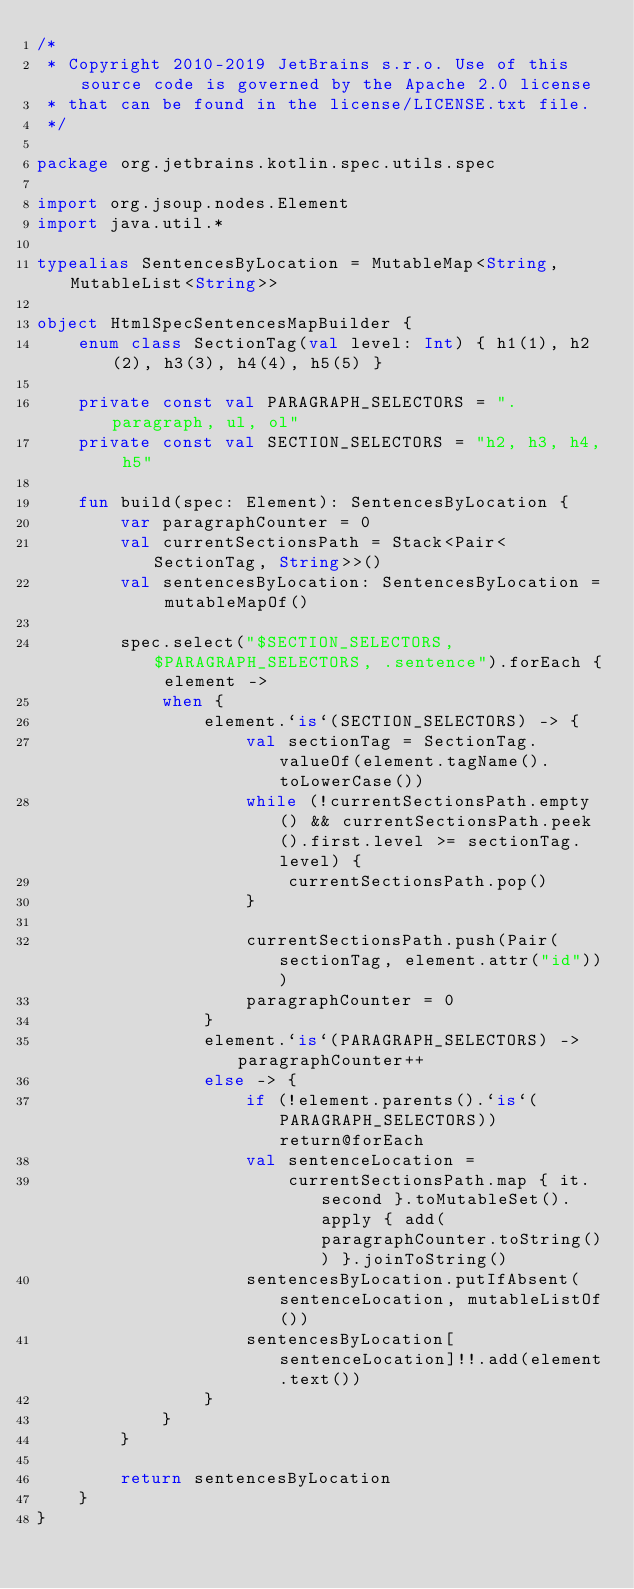Convert code to text. <code><loc_0><loc_0><loc_500><loc_500><_Kotlin_>/*
 * Copyright 2010-2019 JetBrains s.r.o. Use of this source code is governed by the Apache 2.0 license
 * that can be found in the license/LICENSE.txt file.
 */

package org.jetbrains.kotlin.spec.utils.spec

import org.jsoup.nodes.Element
import java.util.*

typealias SentencesByLocation = MutableMap<String, MutableList<String>>

object HtmlSpecSentencesMapBuilder {
    enum class SectionTag(val level: Int) { h1(1), h2(2), h3(3), h4(4), h5(5) }

    private const val PARAGRAPH_SELECTORS = ".paragraph, ul, ol"
    private const val SECTION_SELECTORS = "h2, h3, h4, h5"

    fun build(spec: Element): SentencesByLocation {
        var paragraphCounter = 0
        val currentSectionsPath = Stack<Pair<SectionTag, String>>()
        val sentencesByLocation: SentencesByLocation = mutableMapOf()

        spec.select("$SECTION_SELECTORS, $PARAGRAPH_SELECTORS, .sentence").forEach { element ->
            when {
                element.`is`(SECTION_SELECTORS) -> {
                    val sectionTag = SectionTag.valueOf(element.tagName().toLowerCase())
                    while (!currentSectionsPath.empty() && currentSectionsPath.peek().first.level >= sectionTag.level) {
                        currentSectionsPath.pop()
                    }

                    currentSectionsPath.push(Pair(sectionTag, element.attr("id")))
                    paragraphCounter = 0
                }
                element.`is`(PARAGRAPH_SELECTORS) -> paragraphCounter++
                else -> {
                    if (!element.parents().`is`(PARAGRAPH_SELECTORS)) return@forEach
                    val sentenceLocation =
                        currentSectionsPath.map { it.second }.toMutableSet().apply { add(paragraphCounter.toString()) }.joinToString()
                    sentencesByLocation.putIfAbsent(sentenceLocation, mutableListOf())
                    sentencesByLocation[sentenceLocation]!!.add(element.text())
                }
            }
        }

        return sentencesByLocation
    }
}</code> 